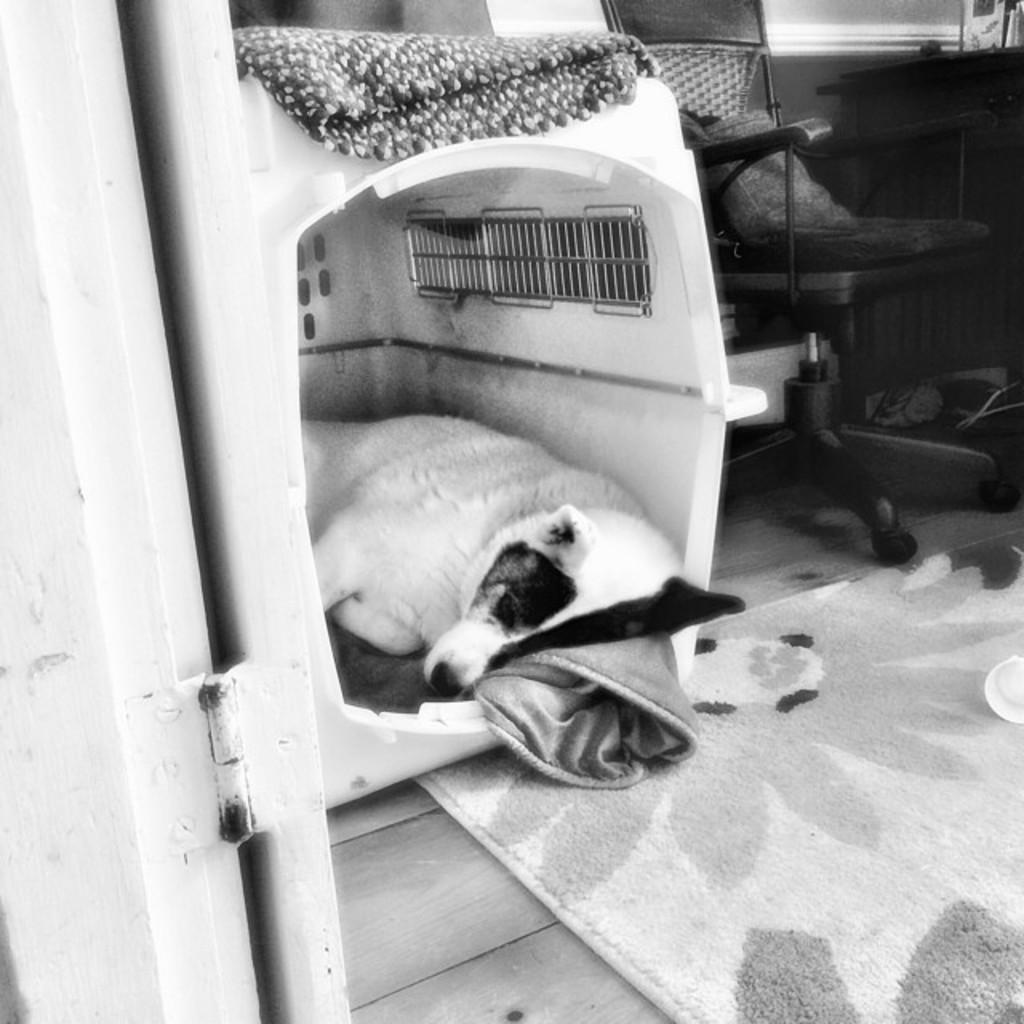Can you describe this image briefly? In the image we can see there is a dog sleeping in a box and inside there is a chair. There is a floor mat on the floor and the image is in black and white colour. 